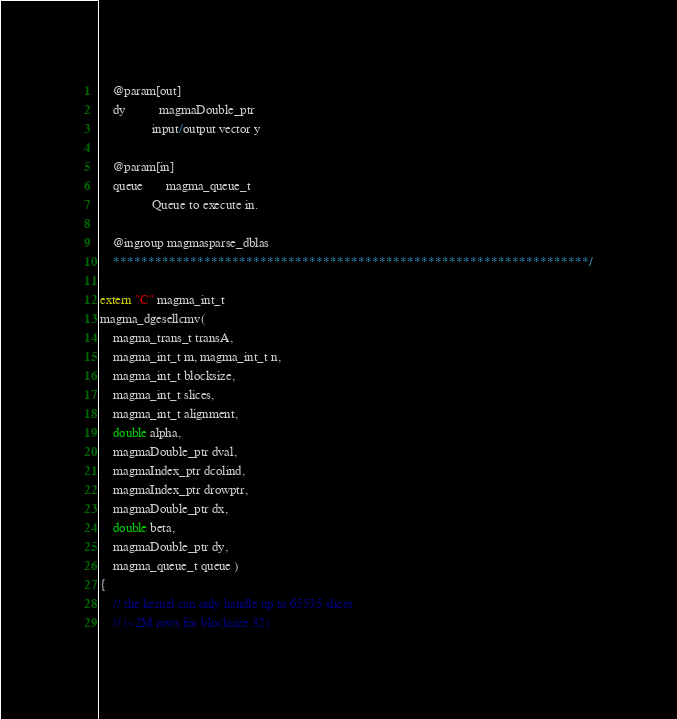<code> <loc_0><loc_0><loc_500><loc_500><_Cuda_>    @param[out]
    dy          magmaDouble_ptr
                input/output vector y

    @param[in]
    queue       magma_queue_t
                Queue to execute in.

    @ingroup magmasparse_dblas
    ********************************************************************/

extern "C" magma_int_t
magma_dgesellcmv(
    magma_trans_t transA,
    magma_int_t m, magma_int_t n,
    magma_int_t blocksize,
    magma_int_t slices,
    magma_int_t alignment,
    double alpha,
    magmaDouble_ptr dval,
    magmaIndex_ptr dcolind,
    magmaIndex_ptr drowptr,
    magmaDouble_ptr dx,
    double beta,
    magmaDouble_ptr dy,
    magma_queue_t queue )
{
    // the kernel can only handle up to 65535 slices 
    // (~2M rows for blocksize 32)</code> 